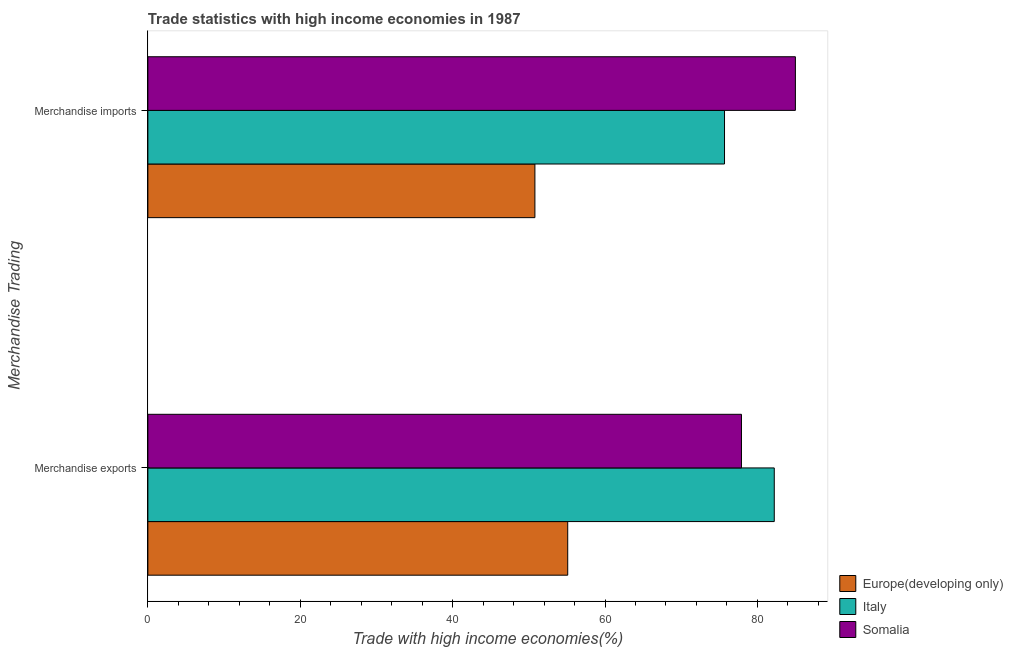How many different coloured bars are there?
Ensure brevity in your answer.  3. Are the number of bars per tick equal to the number of legend labels?
Your answer should be compact. Yes. Are the number of bars on each tick of the Y-axis equal?
Make the answer very short. Yes. How many bars are there on the 2nd tick from the top?
Keep it short and to the point. 3. How many bars are there on the 2nd tick from the bottom?
Offer a very short reply. 3. What is the merchandise imports in Europe(developing only)?
Your answer should be very brief. 50.8. Across all countries, what is the maximum merchandise imports?
Provide a short and direct response. 84.99. Across all countries, what is the minimum merchandise exports?
Offer a terse response. 55.11. In which country was the merchandise exports minimum?
Offer a very short reply. Europe(developing only). What is the total merchandise exports in the graph?
Your answer should be compact. 215.24. What is the difference between the merchandise imports in Somalia and that in Europe(developing only)?
Your answer should be very brief. 34.19. What is the difference between the merchandise imports in Europe(developing only) and the merchandise exports in Italy?
Keep it short and to the point. -31.42. What is the average merchandise imports per country?
Provide a succinct answer. 70.49. What is the difference between the merchandise exports and merchandise imports in Italy?
Your response must be concise. 6.53. What is the ratio of the merchandise exports in Italy to that in Europe(developing only)?
Your answer should be very brief. 1.49. What does the 3rd bar from the top in Merchandise imports represents?
Offer a very short reply. Europe(developing only). What does the 3rd bar from the bottom in Merchandise exports represents?
Ensure brevity in your answer.  Somalia. How many countries are there in the graph?
Provide a short and direct response. 3. What is the difference between two consecutive major ticks on the X-axis?
Offer a very short reply. 20. Does the graph contain any zero values?
Keep it short and to the point. No. Where does the legend appear in the graph?
Keep it short and to the point. Bottom right. How many legend labels are there?
Your answer should be compact. 3. What is the title of the graph?
Give a very brief answer. Trade statistics with high income economies in 1987. Does "St. Martin (French part)" appear as one of the legend labels in the graph?
Offer a terse response. No. What is the label or title of the X-axis?
Your answer should be very brief. Trade with high income economies(%). What is the label or title of the Y-axis?
Give a very brief answer. Merchandise Trading. What is the Trade with high income economies(%) of Europe(developing only) in Merchandise exports?
Your response must be concise. 55.11. What is the Trade with high income economies(%) in Italy in Merchandise exports?
Make the answer very short. 82.22. What is the Trade with high income economies(%) in Somalia in Merchandise exports?
Ensure brevity in your answer.  77.91. What is the Trade with high income economies(%) in Europe(developing only) in Merchandise imports?
Ensure brevity in your answer.  50.8. What is the Trade with high income economies(%) of Italy in Merchandise imports?
Ensure brevity in your answer.  75.69. What is the Trade with high income economies(%) in Somalia in Merchandise imports?
Provide a succinct answer. 84.99. Across all Merchandise Trading, what is the maximum Trade with high income economies(%) in Europe(developing only)?
Make the answer very short. 55.11. Across all Merchandise Trading, what is the maximum Trade with high income economies(%) in Italy?
Offer a very short reply. 82.22. Across all Merchandise Trading, what is the maximum Trade with high income economies(%) of Somalia?
Give a very brief answer. 84.99. Across all Merchandise Trading, what is the minimum Trade with high income economies(%) of Europe(developing only)?
Your answer should be compact. 50.8. Across all Merchandise Trading, what is the minimum Trade with high income economies(%) of Italy?
Provide a succinct answer. 75.69. Across all Merchandise Trading, what is the minimum Trade with high income economies(%) of Somalia?
Your response must be concise. 77.91. What is the total Trade with high income economies(%) in Europe(developing only) in the graph?
Provide a succinct answer. 105.91. What is the total Trade with high income economies(%) of Italy in the graph?
Provide a succinct answer. 157.91. What is the total Trade with high income economies(%) in Somalia in the graph?
Your answer should be very brief. 162.9. What is the difference between the Trade with high income economies(%) of Europe(developing only) in Merchandise exports and that in Merchandise imports?
Ensure brevity in your answer.  4.31. What is the difference between the Trade with high income economies(%) of Italy in Merchandise exports and that in Merchandise imports?
Offer a terse response. 6.53. What is the difference between the Trade with high income economies(%) in Somalia in Merchandise exports and that in Merchandise imports?
Your answer should be compact. -7.08. What is the difference between the Trade with high income economies(%) in Europe(developing only) in Merchandise exports and the Trade with high income economies(%) in Italy in Merchandise imports?
Provide a short and direct response. -20.58. What is the difference between the Trade with high income economies(%) in Europe(developing only) in Merchandise exports and the Trade with high income economies(%) in Somalia in Merchandise imports?
Your answer should be compact. -29.88. What is the difference between the Trade with high income economies(%) in Italy in Merchandise exports and the Trade with high income economies(%) in Somalia in Merchandise imports?
Offer a terse response. -2.77. What is the average Trade with high income economies(%) of Europe(developing only) per Merchandise Trading?
Provide a succinct answer. 52.95. What is the average Trade with high income economies(%) in Italy per Merchandise Trading?
Offer a very short reply. 78.95. What is the average Trade with high income economies(%) in Somalia per Merchandise Trading?
Give a very brief answer. 81.45. What is the difference between the Trade with high income economies(%) of Europe(developing only) and Trade with high income economies(%) of Italy in Merchandise exports?
Provide a succinct answer. -27.11. What is the difference between the Trade with high income economies(%) in Europe(developing only) and Trade with high income economies(%) in Somalia in Merchandise exports?
Provide a succinct answer. -22.81. What is the difference between the Trade with high income economies(%) of Italy and Trade with high income economies(%) of Somalia in Merchandise exports?
Ensure brevity in your answer.  4.3. What is the difference between the Trade with high income economies(%) in Europe(developing only) and Trade with high income economies(%) in Italy in Merchandise imports?
Keep it short and to the point. -24.89. What is the difference between the Trade with high income economies(%) of Europe(developing only) and Trade with high income economies(%) of Somalia in Merchandise imports?
Provide a short and direct response. -34.19. What is the difference between the Trade with high income economies(%) in Italy and Trade with high income economies(%) in Somalia in Merchandise imports?
Your response must be concise. -9.3. What is the ratio of the Trade with high income economies(%) in Europe(developing only) in Merchandise exports to that in Merchandise imports?
Your answer should be compact. 1.08. What is the ratio of the Trade with high income economies(%) in Italy in Merchandise exports to that in Merchandise imports?
Your answer should be very brief. 1.09. What is the ratio of the Trade with high income economies(%) of Somalia in Merchandise exports to that in Merchandise imports?
Ensure brevity in your answer.  0.92. What is the difference between the highest and the second highest Trade with high income economies(%) in Europe(developing only)?
Your answer should be compact. 4.31. What is the difference between the highest and the second highest Trade with high income economies(%) in Italy?
Give a very brief answer. 6.53. What is the difference between the highest and the second highest Trade with high income economies(%) in Somalia?
Provide a short and direct response. 7.08. What is the difference between the highest and the lowest Trade with high income economies(%) of Europe(developing only)?
Offer a terse response. 4.31. What is the difference between the highest and the lowest Trade with high income economies(%) of Italy?
Your answer should be very brief. 6.53. What is the difference between the highest and the lowest Trade with high income economies(%) of Somalia?
Ensure brevity in your answer.  7.08. 